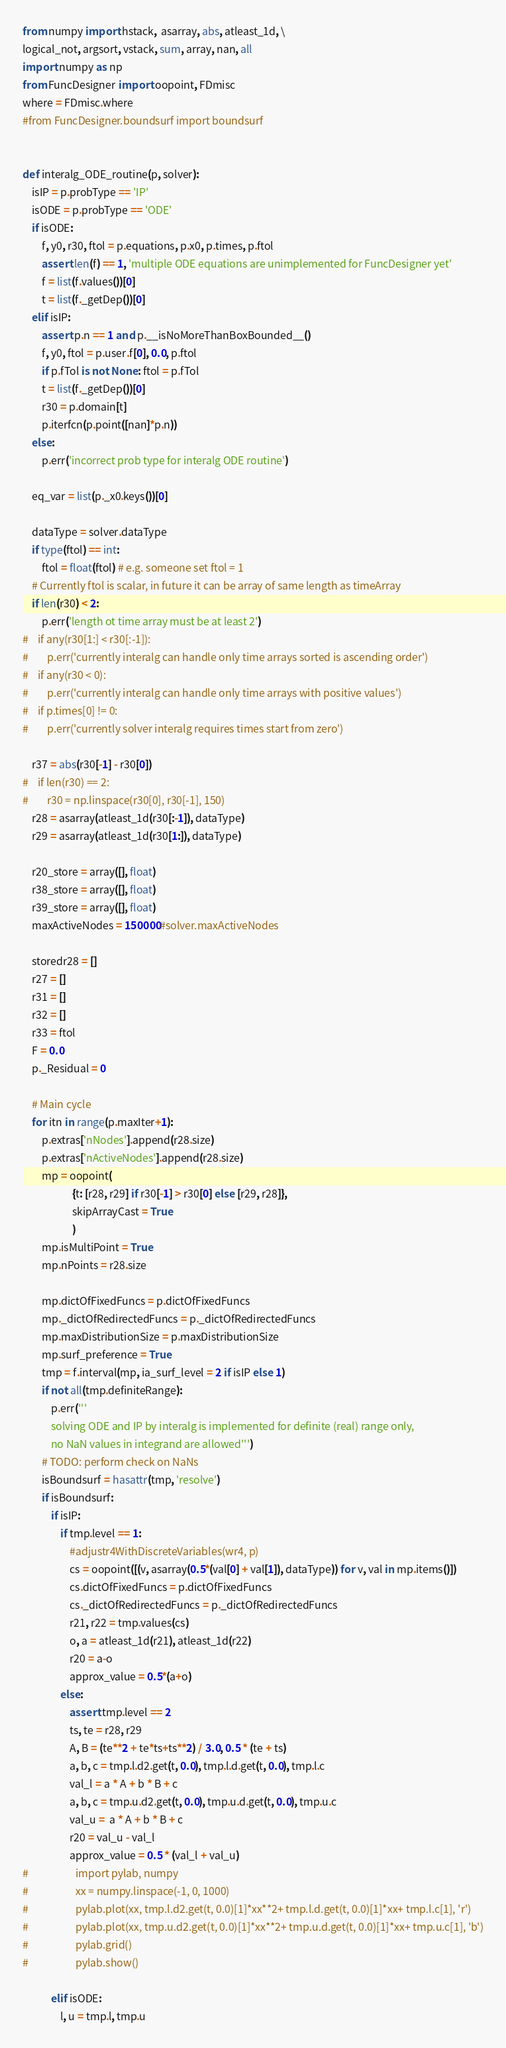<code> <loc_0><loc_0><loc_500><loc_500><_Python_>from numpy import hstack,  asarray, abs, atleast_1d, \
logical_not, argsort, vstack, sum, array, nan, all
import numpy as np
from FuncDesigner import oopoint, FDmisc
where = FDmisc.where
#from FuncDesigner.boundsurf import boundsurf


def interalg_ODE_routine(p, solver):
    isIP = p.probType == 'IP'
    isODE = p.probType == 'ODE'
    if isODE:
        f, y0, r30, ftol = p.equations, p.x0, p.times, p.ftol
        assert len(f) == 1, 'multiple ODE equations are unimplemented for FuncDesigner yet'
        f = list(f.values())[0]
        t = list(f._getDep())[0]
    elif isIP:
        assert p.n == 1 and p.__isNoMoreThanBoxBounded__()
        f, y0, ftol = p.user.f[0], 0.0, p.ftol
        if p.fTol is not None: ftol = p.fTol
        t = list(f._getDep())[0]
        r30 = p.domain[t]
        p.iterfcn(p.point([nan]*p.n))
    else:
        p.err('incorrect prob type for interalg ODE routine') 
    
    eq_var = list(p._x0.keys())[0]

    dataType = solver.dataType
    if type(ftol) == int: 
        ftol = float(ftol) # e.g. someone set ftol = 1
    # Currently ftol is scalar, in future it can be array of same length as timeArray
    if len(r30) < 2:
        p.err('length ot time array must be at least 2')    
#    if any(r30[1:] < r30[:-1]):
#        p.err('currently interalg can handle only time arrays sorted is ascending order')  
#    if any(r30 < 0):
#        p.err('currently interalg can handle only time arrays with positive values')  
#    if p.times[0] != 0:
#        p.err('currently solver interalg requires times start from zero')  
    
    r37 = abs(r30[-1] - r30[0])
#    if len(r30) == 2:
#        r30 = np.linspace(r30[0], r30[-1], 150)
    r28 = asarray(atleast_1d(r30[:-1]), dataType)
    r29 = asarray(atleast_1d(r30[1:]), dataType)
    
    r20_store = array([], float)
    r38_store = array([], float)
    r39_store = array([], float)
    maxActiveNodes = 150000#solver.maxActiveNodes

    storedr28 = []
    r27 = []
    r31 = []
    r32 = []
    r33 = ftol
    F = 0.0
    p._Residual = 0
    
    # Main cycle
    for itn in range(p.maxIter+1):
        p.extras['nNodes'].append(r28.size)
        p.extras['nActiveNodes'].append(r28.size)
        mp = oopoint(
                     {t: [r28, r29] if r30[-1] > r30[0] else [r29, r28]}, 
                     skipArrayCast = True
                     )
        mp.isMultiPoint = True
        mp.nPoints = r28.size
        
        mp.dictOfFixedFuncs = p.dictOfFixedFuncs
        mp._dictOfRedirectedFuncs = p._dictOfRedirectedFuncs
        mp.maxDistributionSize = p.maxDistributionSize
        mp.surf_preference = True
        tmp = f.interval(mp, ia_surf_level = 2 if isIP else 1)
        if not all(tmp.definiteRange):
            p.err('''
            solving ODE and IP by interalg is implemented for definite (real) range only, 
            no NaN values in integrand are allowed''')
        # TODO: perform check on NaNs
        isBoundsurf = hasattr(tmp, 'resolve')
        if isBoundsurf:
            if isIP:
                if tmp.level == 1:
                    #adjustr4WithDiscreteVariables(wr4, p)
                    cs = oopoint([(v, asarray(0.5*(val[0] + val[1]), dataType)) for v, val in mp.items()])
                    cs.dictOfFixedFuncs = p.dictOfFixedFuncs
                    cs._dictOfRedirectedFuncs = p._dictOfRedirectedFuncs
                    r21, r22 = tmp.values(cs)
                    o, a = atleast_1d(r21), atleast_1d(r22)
                    r20 = a-o
                    approx_value = 0.5*(a+o)
                else:
                    assert tmp.level == 2
                    ts, te = r28, r29
                    A, B = (te**2 + te*ts+ts**2) / 3.0, 0.5 * (te + ts)
                    a, b, c = tmp.l.d2.get(t, 0.0), tmp.l.d.get(t, 0.0), tmp.l.c
                    val_l = a * A + b * B + c 
                    a, b, c = tmp.u.d2.get(t, 0.0), tmp.u.d.get(t, 0.0), tmp.u.c
                    val_u =  a * A + b * B + c 
                    r20 = val_u - val_l
                    approx_value = 0.5 * (val_l + val_u)
#                    import pylab, numpy
#                    xx = numpy.linspace(-1, 0, 1000)
#                    pylab.plot(xx, tmp.l.d2.get(t, 0.0)[1]*xx**2+ tmp.l.d.get(t, 0.0)[1]*xx+ tmp.l.c[1], 'r')
#                    pylab.plot(xx, tmp.u.d2.get(t, 0.0)[1]*xx**2+ tmp.u.d.get(t, 0.0)[1]*xx+ tmp.u.c[1], 'b')
#                    pylab.grid()
#                    pylab.show()
                    
            elif isODE:
                l, u = tmp.l, tmp.u</code> 